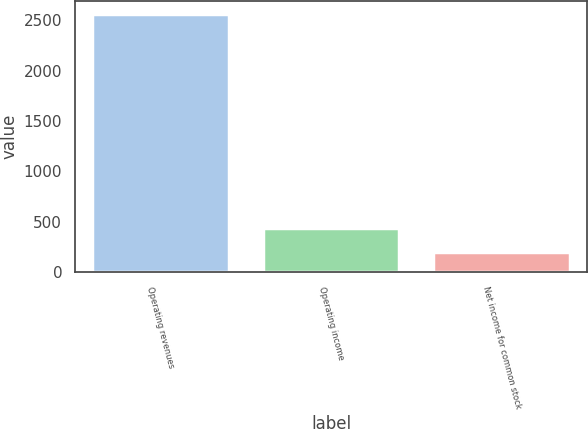<chart> <loc_0><loc_0><loc_500><loc_500><bar_chart><fcel>Operating revenues<fcel>Operating income<fcel>Net income for common stock<nl><fcel>2562<fcel>435.3<fcel>199<nl></chart> 